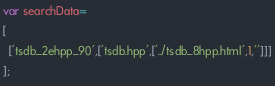<code> <loc_0><loc_0><loc_500><loc_500><_JavaScript_>var searchData=
[
  ['tsdb_2ehpp_90',['tsdb.hpp',['../tsdb_8hpp.html',1,'']]]
];
</code> 